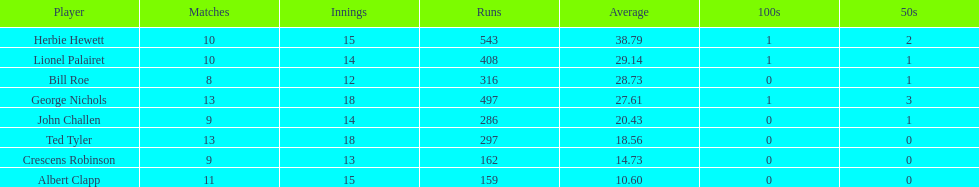What was the total number of innings played by bill and ted? 30. 